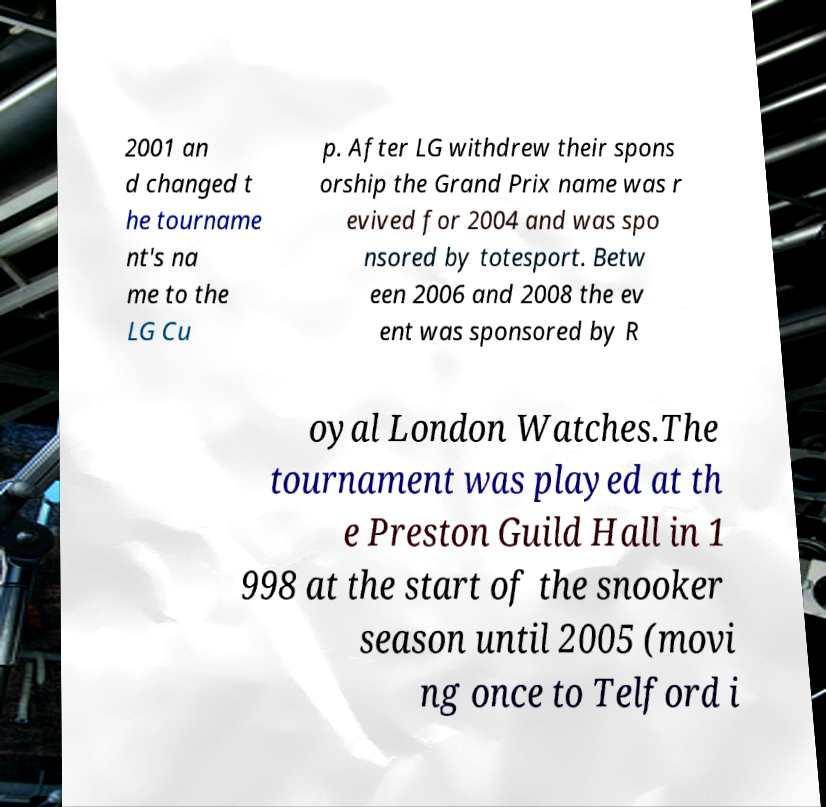Could you assist in decoding the text presented in this image and type it out clearly? 2001 an d changed t he tourname nt's na me to the LG Cu p. After LG withdrew their spons orship the Grand Prix name was r evived for 2004 and was spo nsored by totesport. Betw een 2006 and 2008 the ev ent was sponsored by R oyal London Watches.The tournament was played at th e Preston Guild Hall in 1 998 at the start of the snooker season until 2005 (movi ng once to Telford i 